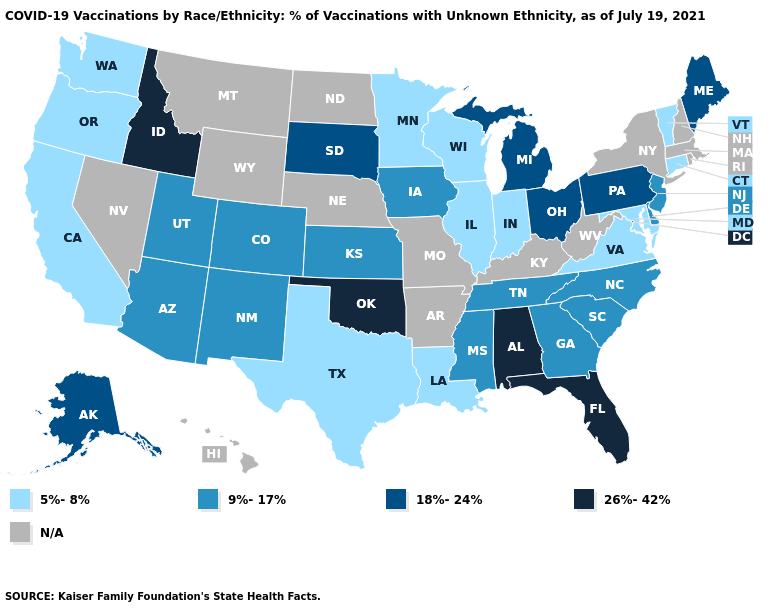How many symbols are there in the legend?
Short answer required. 5. What is the value of Virginia?
Answer briefly. 5%-8%. What is the value of Indiana?
Be succinct. 5%-8%. Name the states that have a value in the range N/A?
Quick response, please. Arkansas, Hawaii, Kentucky, Massachusetts, Missouri, Montana, Nebraska, Nevada, New Hampshire, New York, North Dakota, Rhode Island, West Virginia, Wyoming. How many symbols are there in the legend?
Answer briefly. 5. What is the value of New Hampshire?
Short answer required. N/A. Name the states that have a value in the range 9%-17%?
Keep it brief. Arizona, Colorado, Delaware, Georgia, Iowa, Kansas, Mississippi, New Jersey, New Mexico, North Carolina, South Carolina, Tennessee, Utah. What is the value of Missouri?
Keep it brief. N/A. What is the value of Wyoming?
Concise answer only. N/A. Which states have the lowest value in the West?
Be succinct. California, Oregon, Washington. Name the states that have a value in the range N/A?
Quick response, please. Arkansas, Hawaii, Kentucky, Massachusetts, Missouri, Montana, Nebraska, Nevada, New Hampshire, New York, North Dakota, Rhode Island, West Virginia, Wyoming. What is the value of South Carolina?
Answer briefly. 9%-17%. 